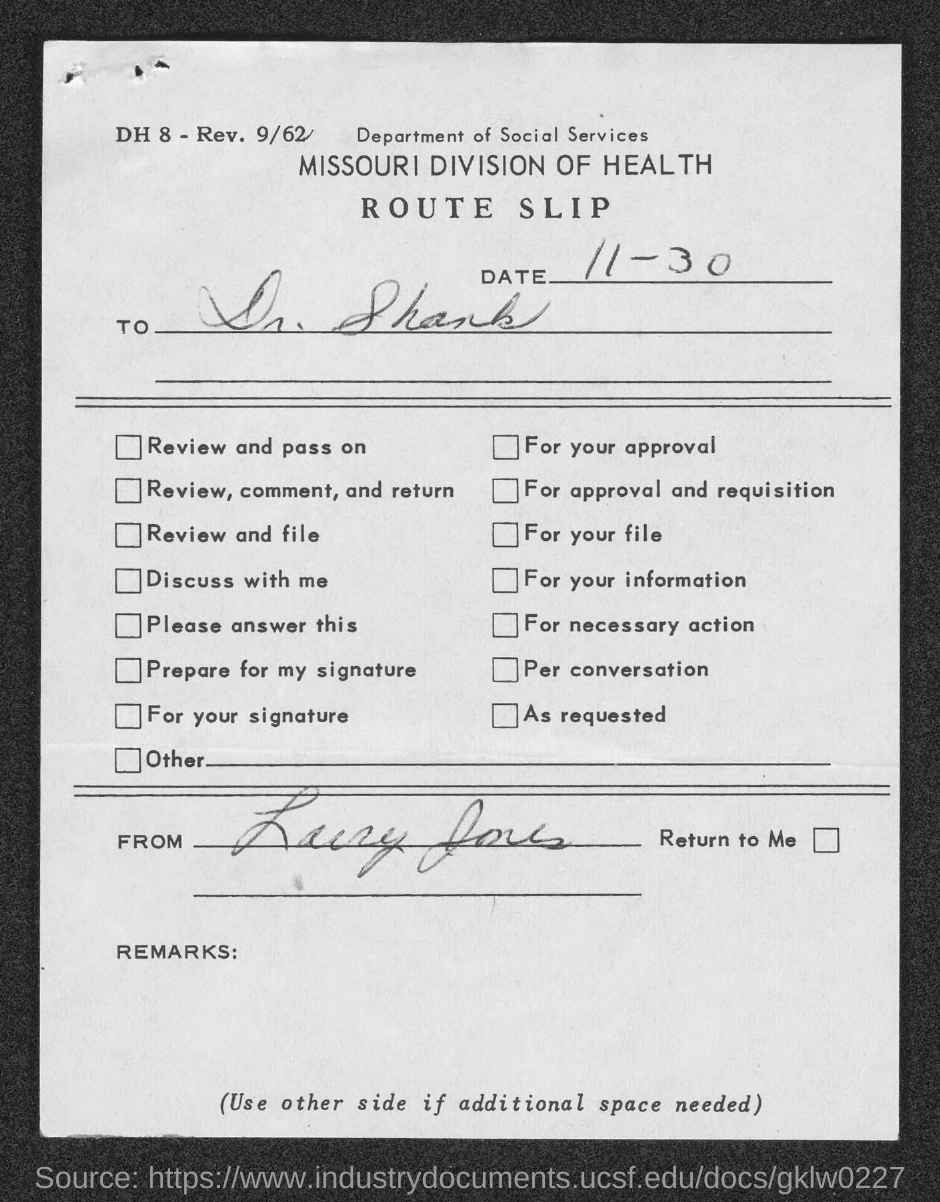Specify some key components in this picture. The route slip is dated November 30th. 